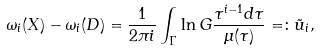Convert formula to latex. <formula><loc_0><loc_0><loc_500><loc_500>\omega _ { i } ( X ) - \omega _ { i } ( D ) = \frac { 1 } { 2 \pi i } \int _ { \Gamma } \ln G \frac { \tau ^ { i - 1 } d \tau } { \mu ( \tau ) } = \colon \tilde { u } _ { i } ,</formula> 